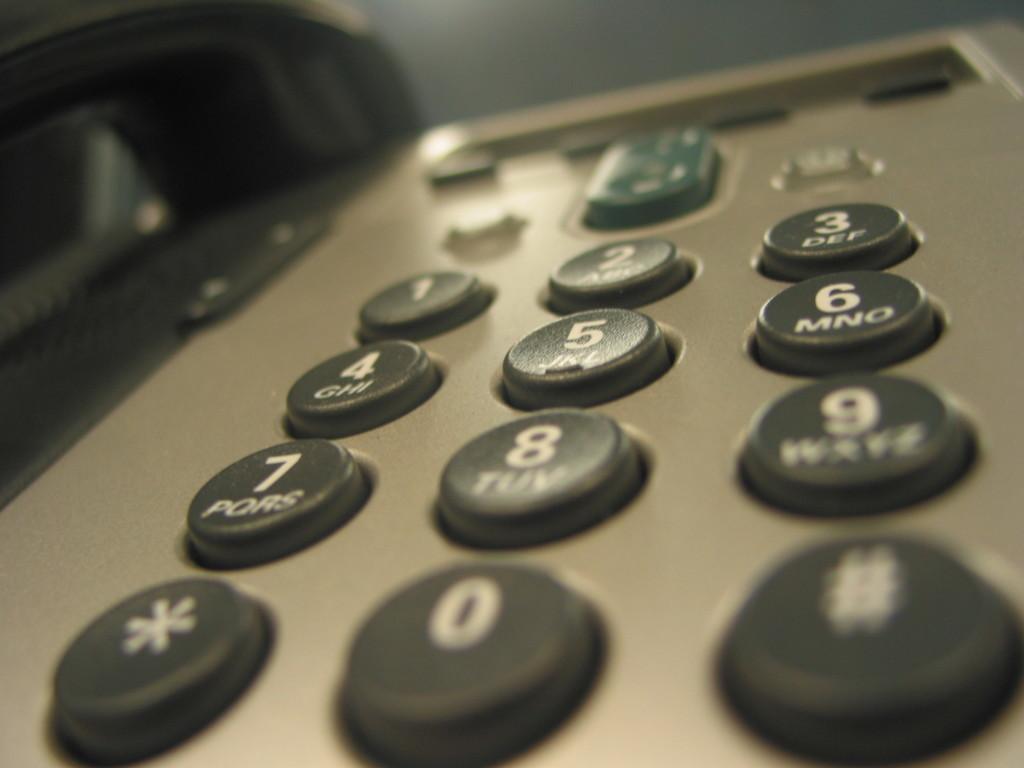What is the bottom left symbol?
Offer a terse response. *. 